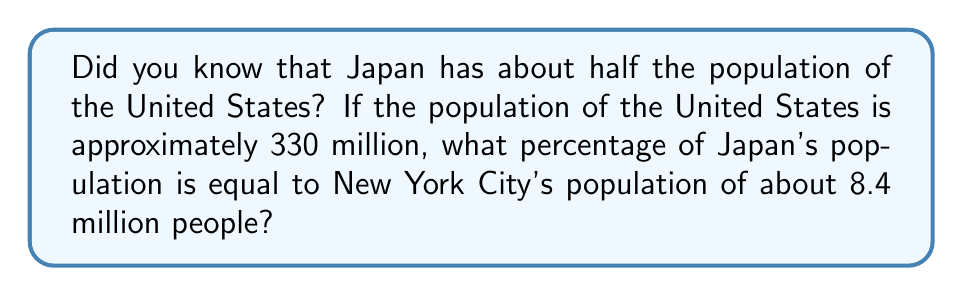Teach me how to tackle this problem. Let's solve this step-by-step:

1. First, we need to calculate Japan's population:
   If Japan has half the population of the US, then:
   $$ \text{Japan's population} = \frac{1}{2} \times 330 \text{ million} = 165 \text{ million} $$

2. Now, we need to find what percentage 8.4 million (NYC's population) is of 165 million (Japan's population):
   $$ \text{Percentage} = \frac{\text{NYC population}}{\text{Japan's population}} \times 100\% $$

3. Let's plug in the numbers:
   $$ \text{Percentage} = \frac{8.4 \text{ million}}{165 \text{ million}} \times 100\% $$

4. Simplify the fraction:
   $$ \text{Percentage} = \frac{8.4}{165} \times 100\% $$

5. Divide 8.4 by 165:
   $$ \text{Percentage} = 0.0509 \times 100\% = 5.09\% $$

6. Round to the nearest tenth of a percent:
   $$ \text{Percentage} \approx 5.1\% $$
Answer: 5.1% 